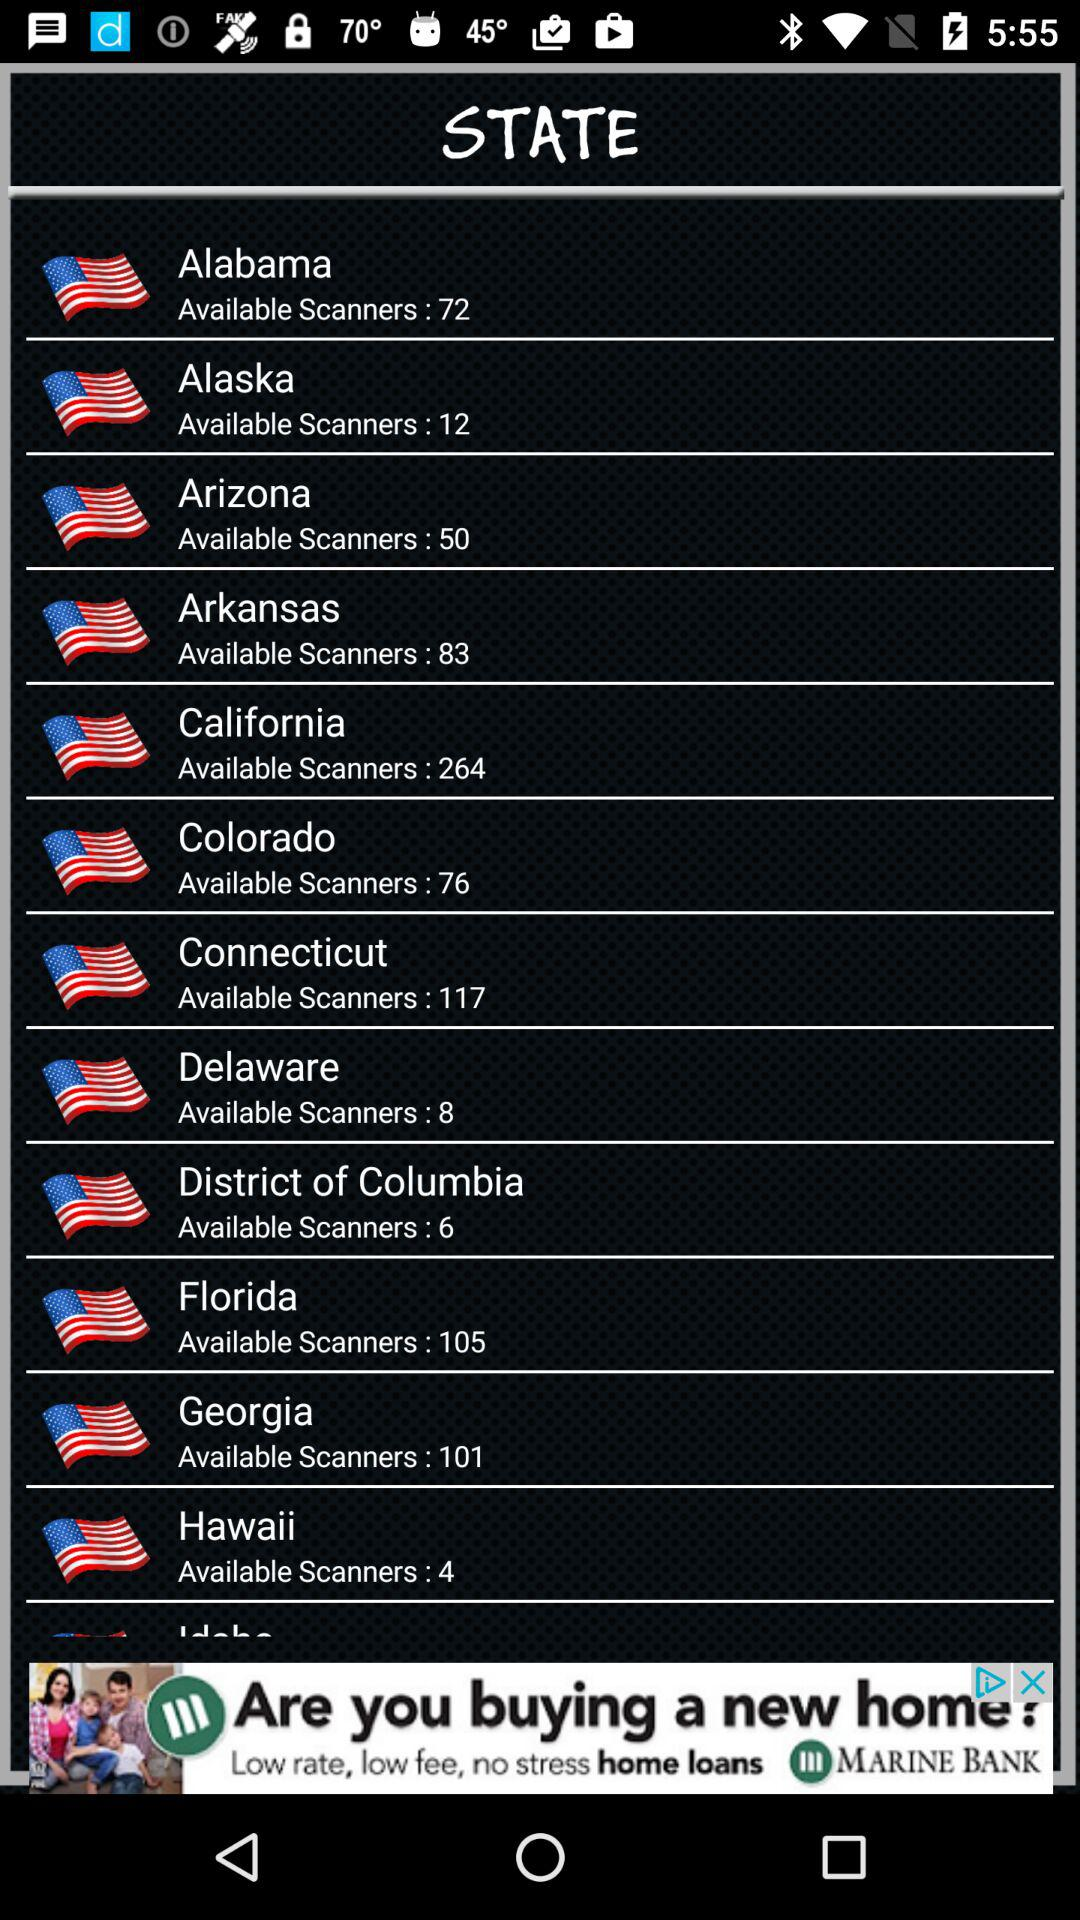How many states have more than 100 available scanners?
Answer the question using a single word or phrase. 4 